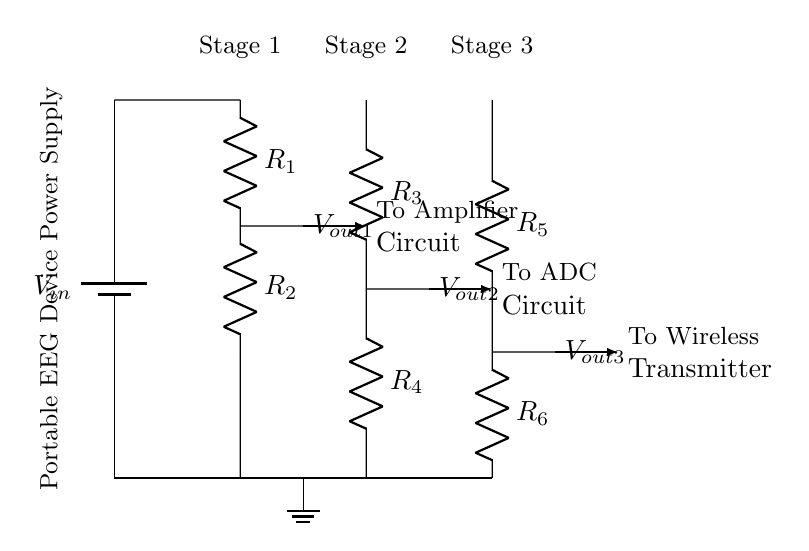What is the input voltage for this circuit? The input voltage is denoted as V_in at the top of the circuit, which represents the supply voltage for the entire voltage divider.
Answer: V_in What are the resistances in the first stage? The first stage of the voltage divider includes resistors R_1 and R_2, which are connected in series.
Answer: R_1 and R_2 What is the purpose of V_out1? V_out1 is the output voltage taken from the junction between R_1 and R_2, which provides a lower voltage to power the amplifier circuit.
Answer: To Amplifier Circuit How many stages are there in this voltage divider circuit? The circuit consists of three stages, each having its own pair of resistors to lower the voltage progressively.
Answer: Three What can be inferred about the total resistance in each stage? Each stage has two resistors in series, so the total resistance for that stage would be the sum of the individual resistances of those two resistors.
Answer: R_1 + R_2, R_3 + R_4, R_5 + R_6 What do the outputs V_out2 and V_out3 connect to? V_out2 connects to the ADC circuit, while V_out3 connects to the wireless transmitter, illustrating the distribution of voltages to different components.
Answer: ADC Circuit and Wireless Transmitter 